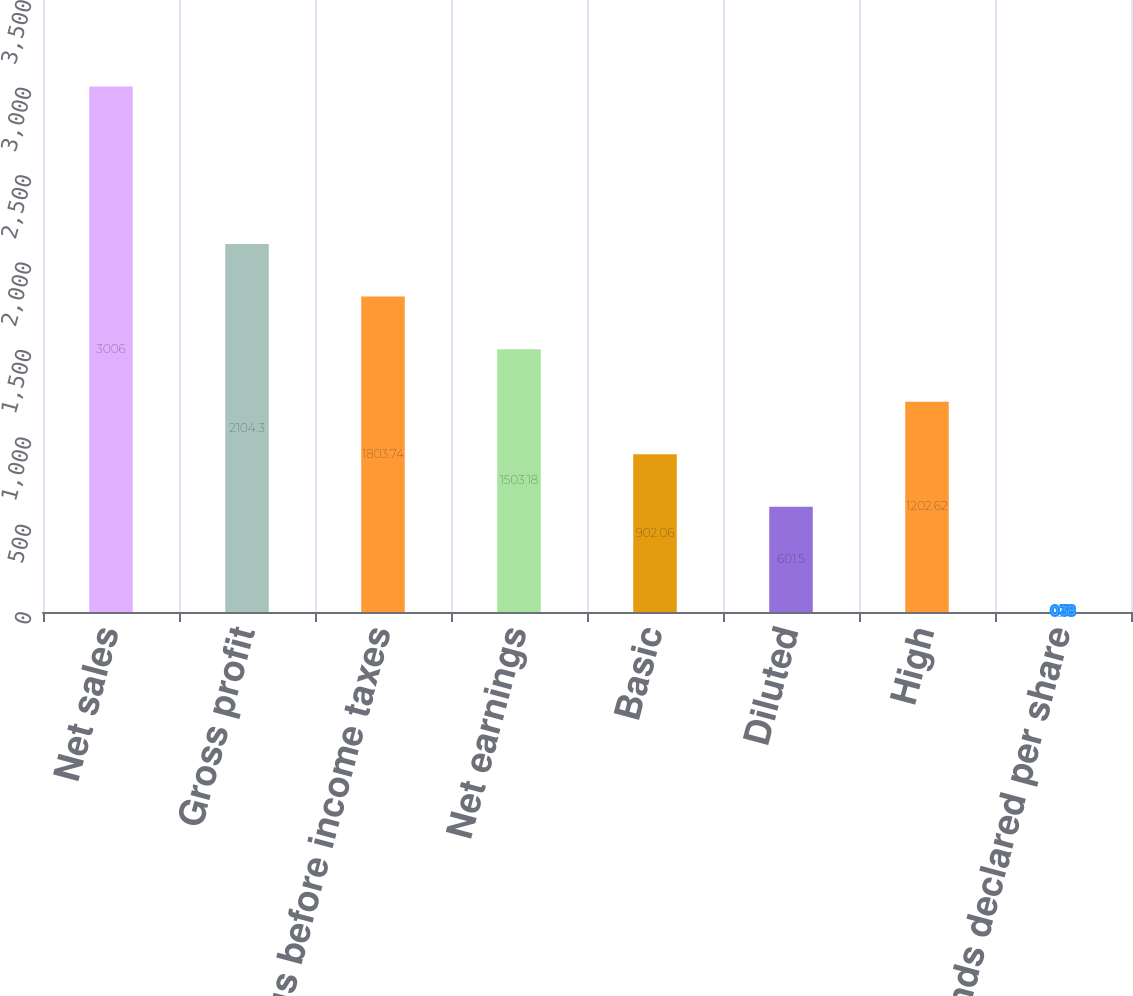Convert chart. <chart><loc_0><loc_0><loc_500><loc_500><bar_chart><fcel>Net sales<fcel>Gross profit<fcel>Earnings before income taxes<fcel>Net earnings<fcel>Basic<fcel>Diluted<fcel>High<fcel>Dividends declared per share<nl><fcel>3006<fcel>2104.3<fcel>1803.74<fcel>1503.18<fcel>902.06<fcel>601.5<fcel>1202.62<fcel>0.38<nl></chart> 